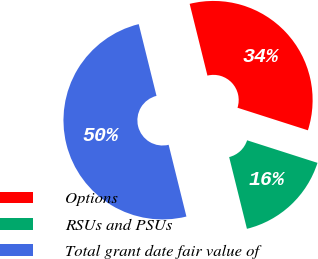<chart> <loc_0><loc_0><loc_500><loc_500><pie_chart><fcel>Options<fcel>RSUs and PSUs<fcel>Total grant date fair value of<nl><fcel>33.8%<fcel>16.2%<fcel>50.0%<nl></chart> 